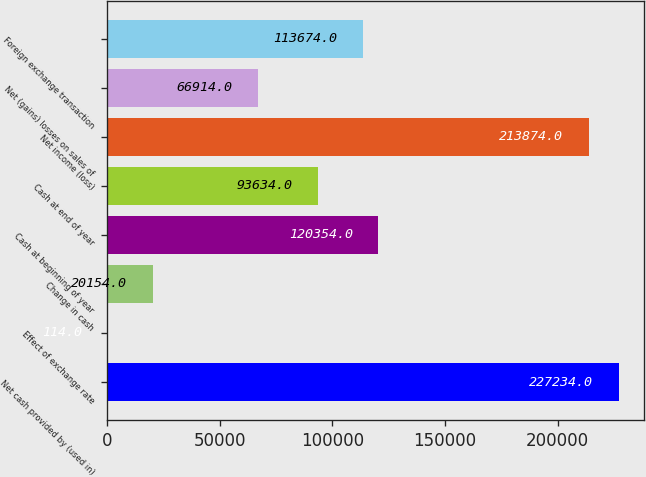Convert chart to OTSL. <chart><loc_0><loc_0><loc_500><loc_500><bar_chart><fcel>Net cash provided by (used in)<fcel>Effect of exchange rate<fcel>Change in cash<fcel>Cash at beginning of year<fcel>Cash at end of year<fcel>Net income (loss)<fcel>Net (gains) losses on sales of<fcel>Foreign exchange transaction<nl><fcel>227234<fcel>114<fcel>20154<fcel>120354<fcel>93634<fcel>213874<fcel>66914<fcel>113674<nl></chart> 